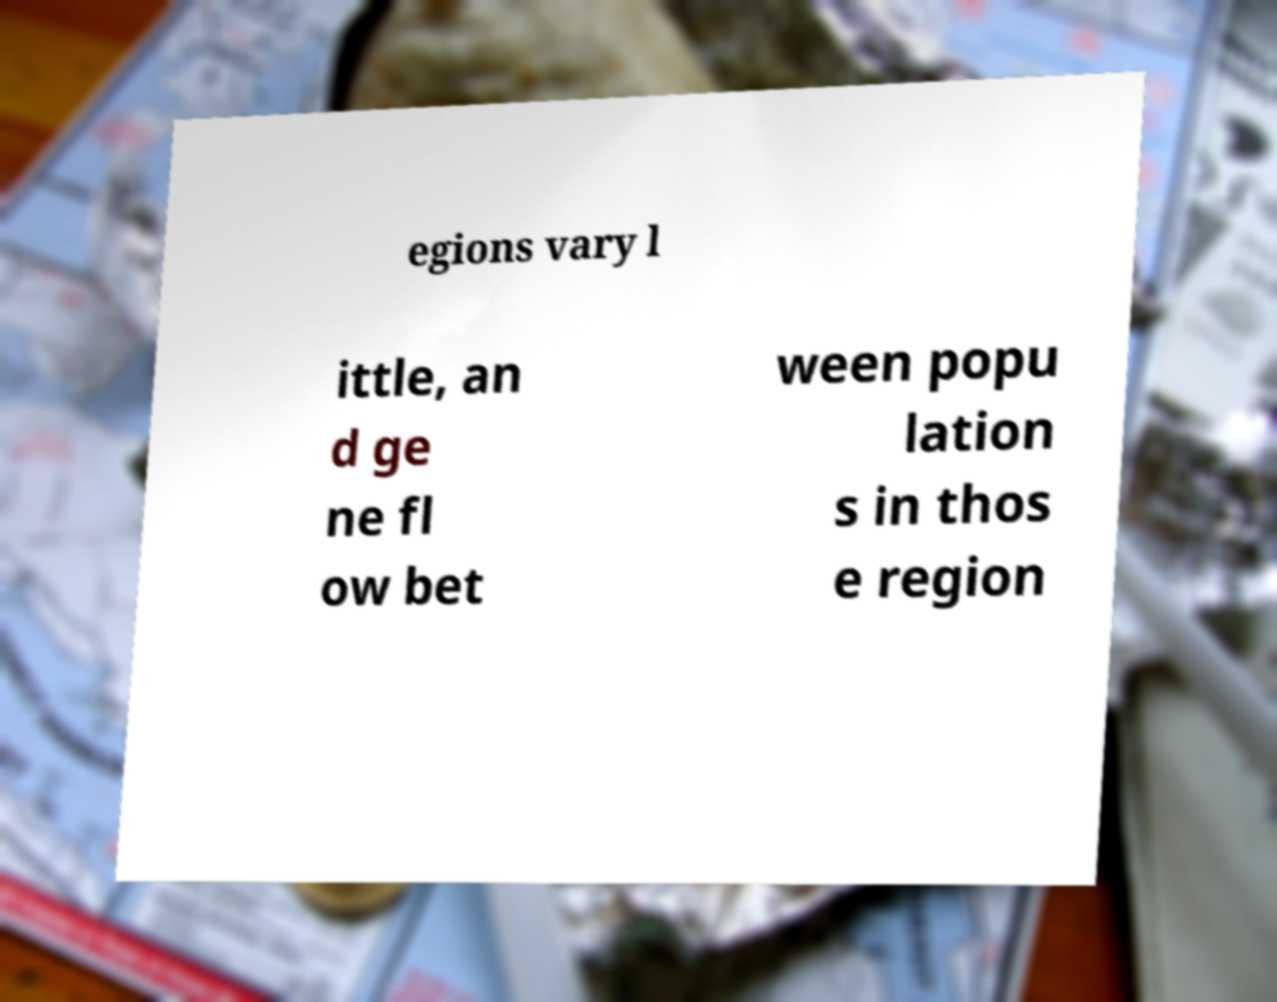Please read and relay the text visible in this image. What does it say? egions vary l ittle, an d ge ne fl ow bet ween popu lation s in thos e region 